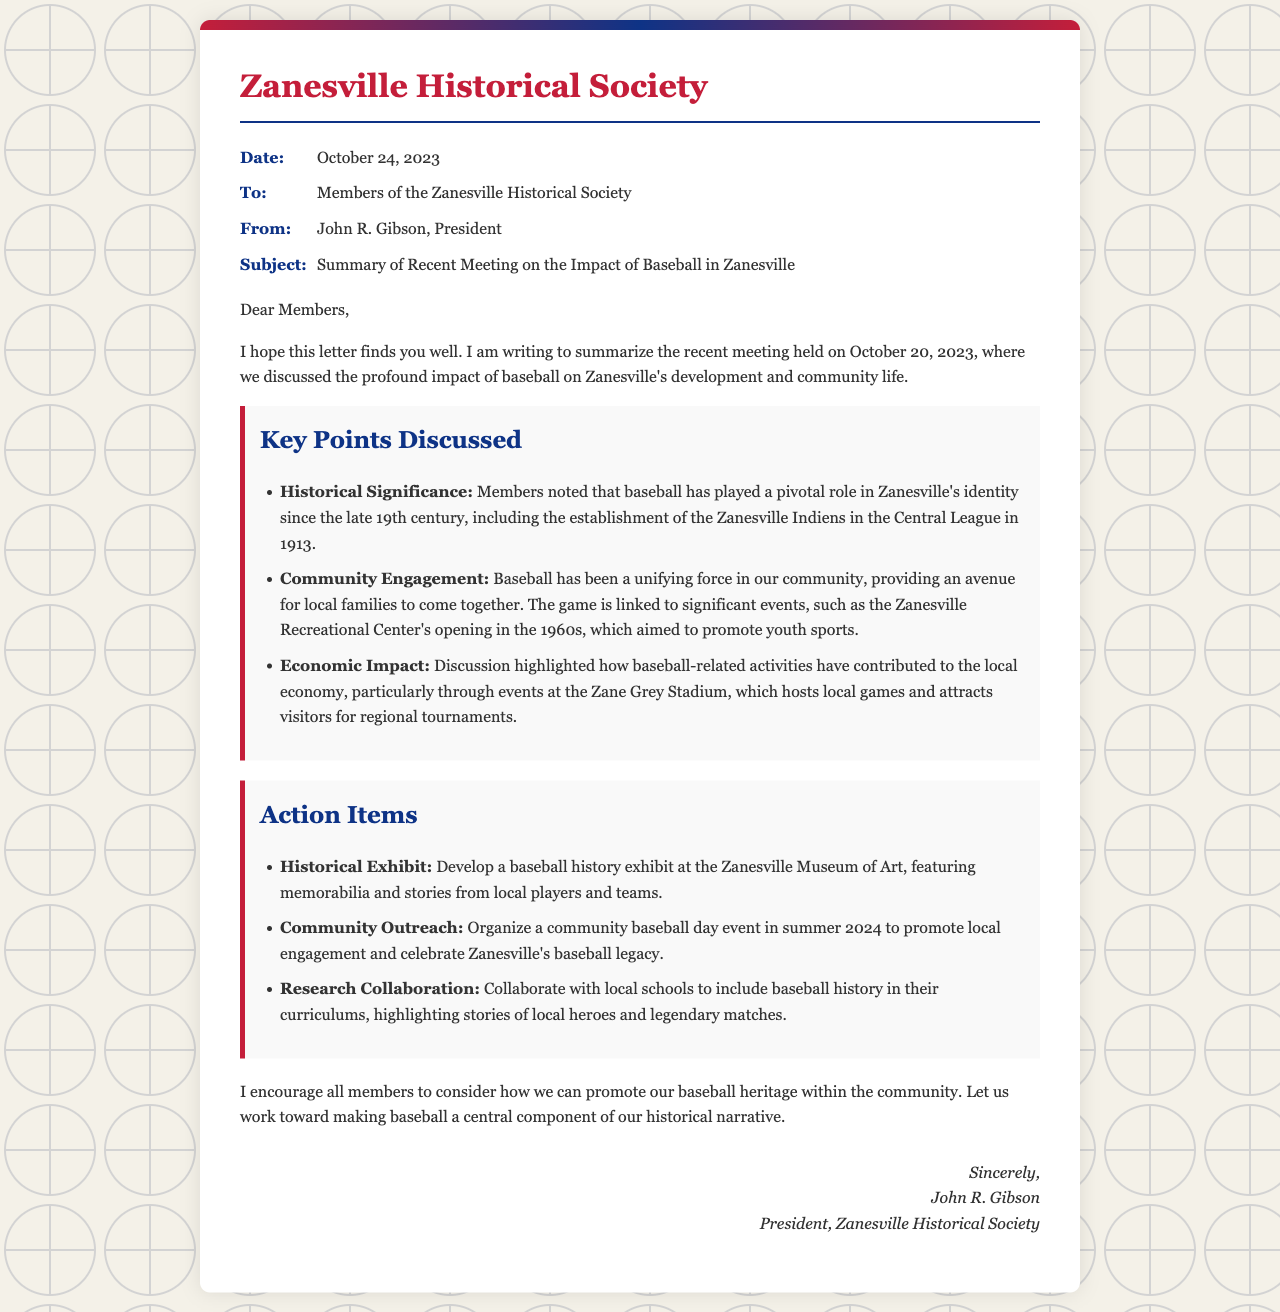what date was the meeting held? The meeting was held on October 20, 2023, as stated in the letter.
Answer: October 20, 2023 who is the author of the letter? The letter is written by John R. Gibson, as mentioned in the "From" section.
Answer: John R. Gibson what was established in 1913 related to baseball in Zanesville? The Zanesville Indiens were established in 1913, noted in the discussion on historical significance.
Answer: Zanesville Indiens what economic benefit is mentioned related to baseball? The document states that baseball activities contribute to the local economy, particularly through events at Zane Grey Stadium.
Answer: local economy what community event is planned for summer 2024? A community baseball day event is scheduled to promote local engagement and celebrate baseball legacy.
Answer: community baseball day event how does the letter encourage members regarding baseball heritage? The letter encourages members to consider promoting baseball heritage within the community.
Answer: promote baseball heritage what is one action item for historical collaboration? The action item mentions collaborating with local schools to include baseball history in their curriculums.
Answer: collaborate with local schools what significant local facility is linked to baseball in the letter? The Zanesville Recreational Center is mentioned as a significant facility linked to baseball and community engagement.
Answer: Zanesville Recreational Center 